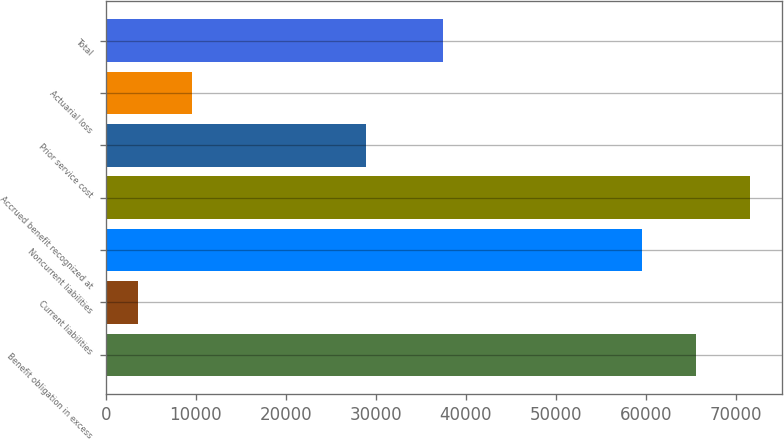Convert chart. <chart><loc_0><loc_0><loc_500><loc_500><bar_chart><fcel>Benefit obligation in excess<fcel>Current liabilities<fcel>Noncurrent liabilities<fcel>Accrued benefit recognized at<fcel>Prior service cost<fcel>Actuarial loss<fcel>Total<nl><fcel>65605.1<fcel>3586<fcel>59641<fcel>71569.2<fcel>28897<fcel>9550.1<fcel>37505<nl></chart> 